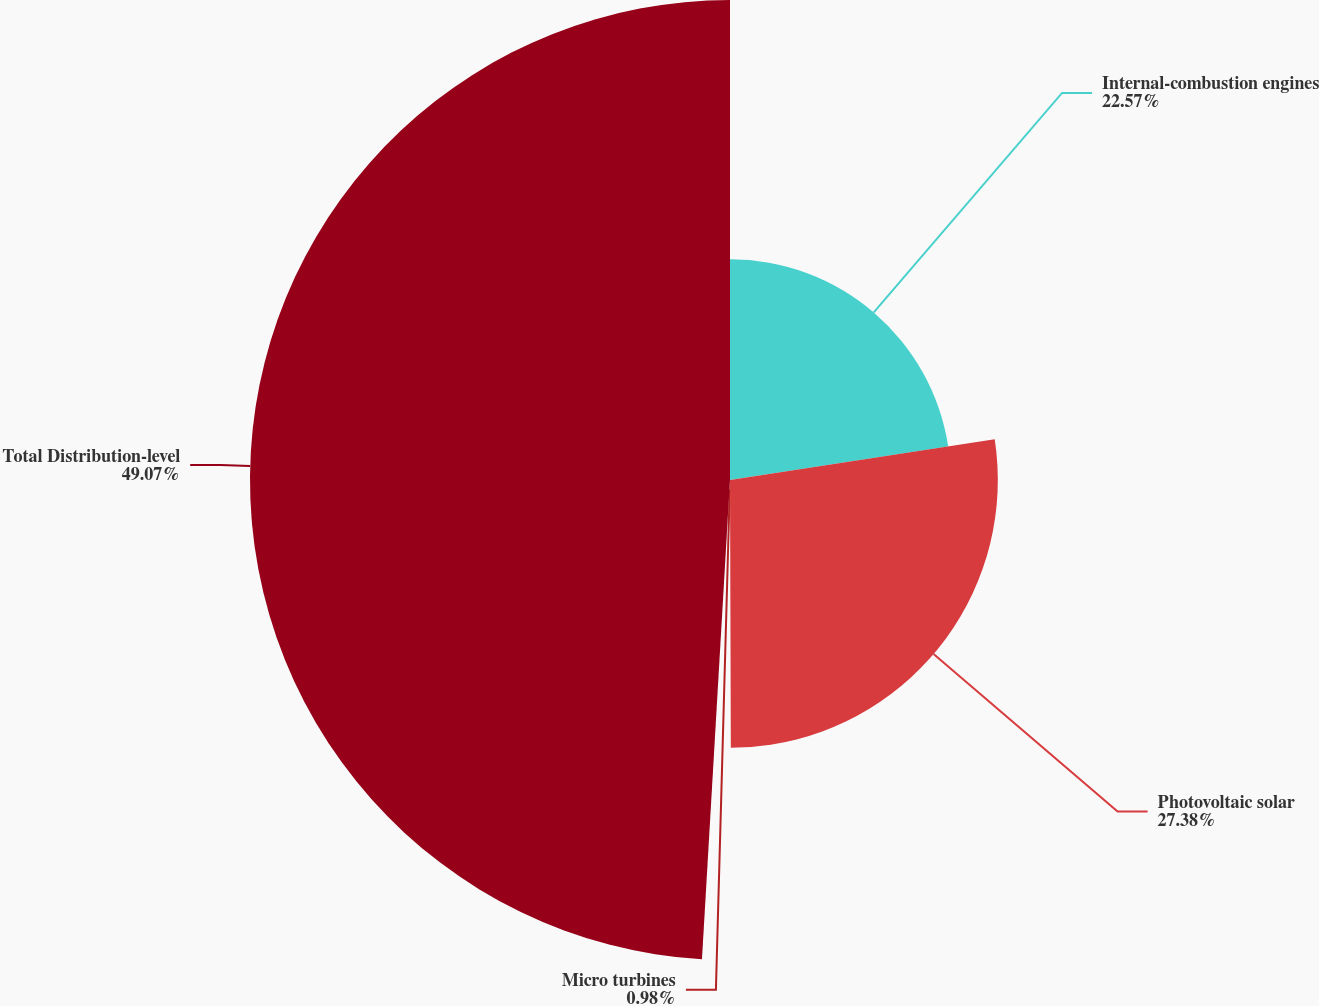Convert chart. <chart><loc_0><loc_0><loc_500><loc_500><pie_chart><fcel>Internal-combustion engines<fcel>Photovoltaic solar<fcel>Micro turbines<fcel>Total Distribution-level<nl><fcel>22.57%<fcel>27.38%<fcel>0.98%<fcel>49.07%<nl></chart> 